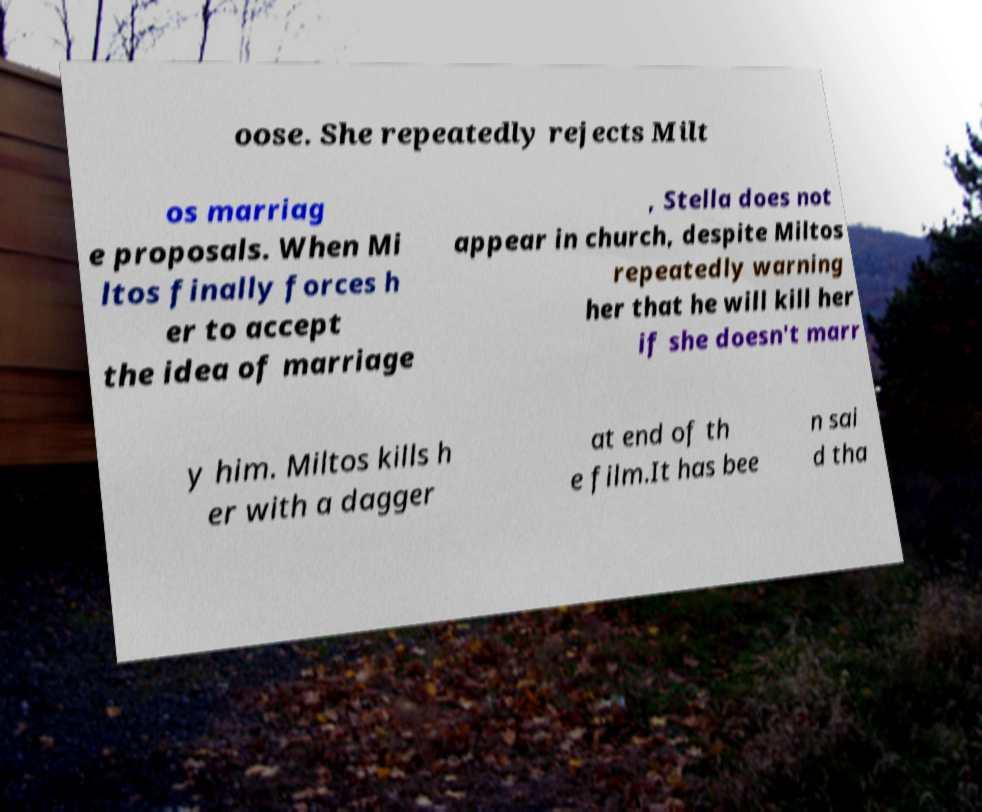Please identify and transcribe the text found in this image. oose. She repeatedly rejects Milt os marriag e proposals. When Mi ltos finally forces h er to accept the idea of marriage , Stella does not appear in church, despite Miltos repeatedly warning her that he will kill her if she doesn't marr y him. Miltos kills h er with a dagger at end of th e film.It has bee n sai d tha 